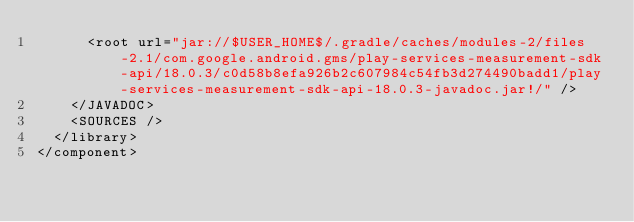<code> <loc_0><loc_0><loc_500><loc_500><_XML_>      <root url="jar://$USER_HOME$/.gradle/caches/modules-2/files-2.1/com.google.android.gms/play-services-measurement-sdk-api/18.0.3/c0d58b8efa926b2c607984c54fb3d274490badd1/play-services-measurement-sdk-api-18.0.3-javadoc.jar!/" />
    </JAVADOC>
    <SOURCES />
  </library>
</component></code> 